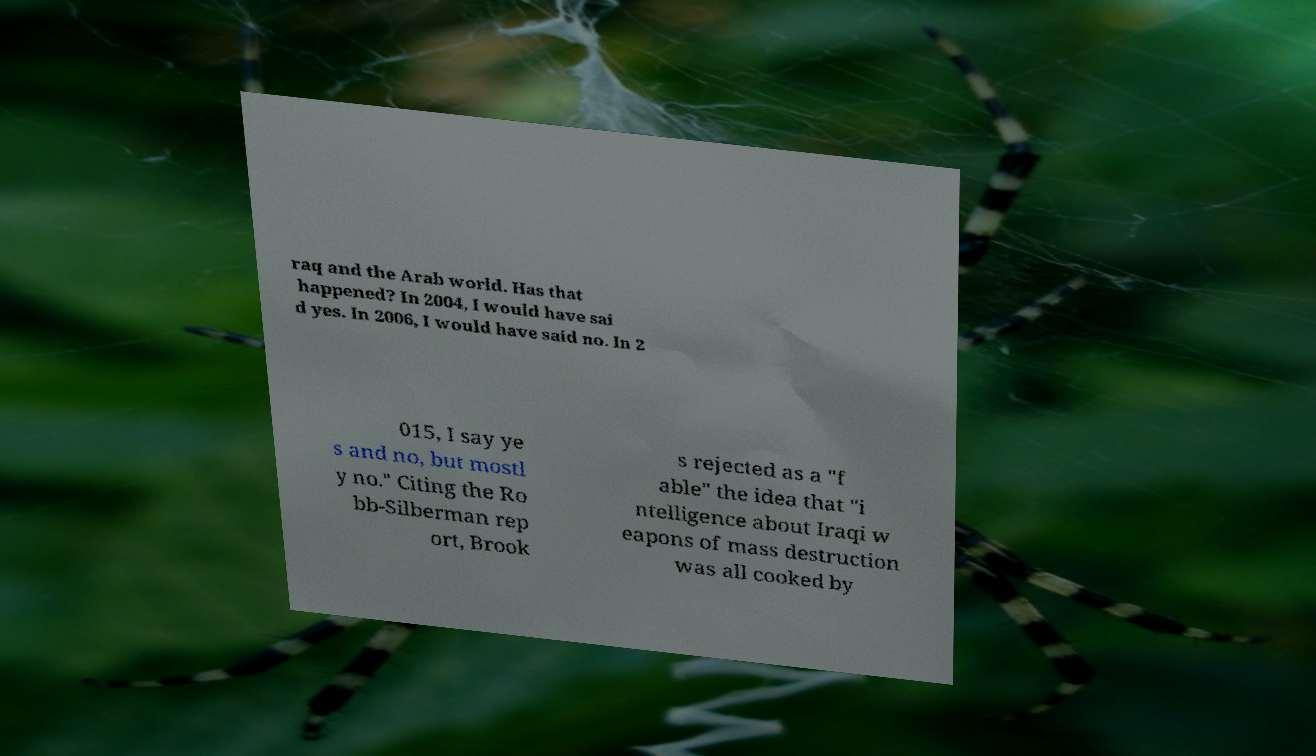Could you assist in decoding the text presented in this image and type it out clearly? raq and the Arab world. Has that happened? In 2004, I would have sai d yes. In 2006, I would have said no. In 2 015, I say ye s and no, but mostl y no." Citing the Ro bb-Silberman rep ort, Brook s rejected as a "f able" the idea that "i ntelligence about Iraqi w eapons of mass destruction was all cooked by 